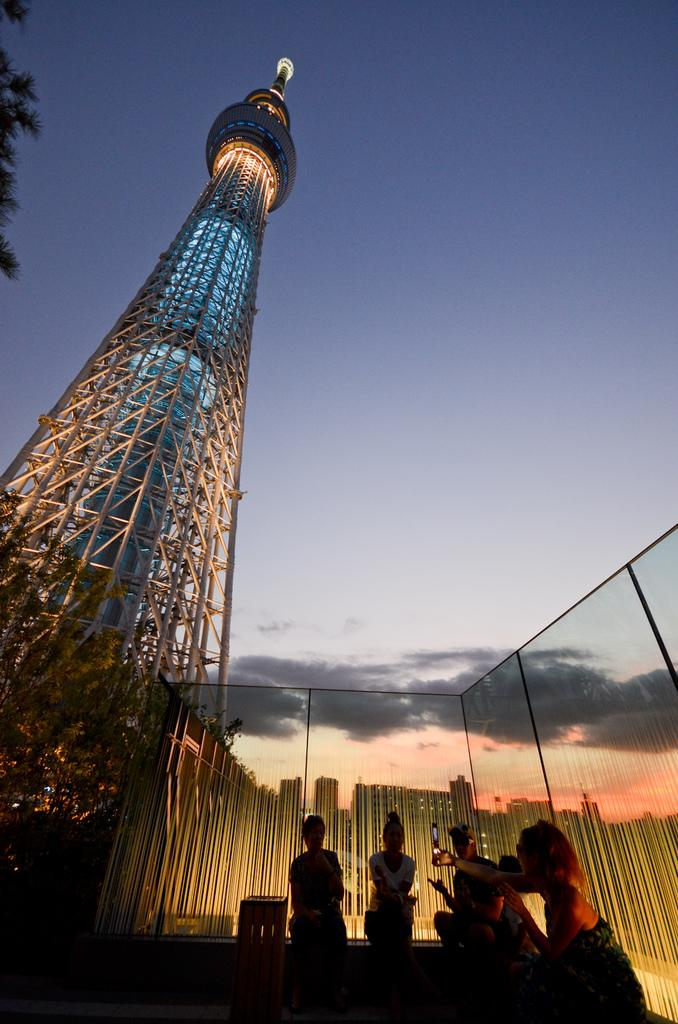What can be seen in the front of the image? There are people in the front of the image. What type of walls are present in the image? There are glass walls in the image. What is located on the left side of the image? There is a building and a tree on the left side of the image. What is visible at the top of the image? The sky is visible at the top of the image. What type of breakfast is being served to the visitor in the image? There is no breakfast or visitor present in the image. What line is visible in the image? There is no line visible in the image. 